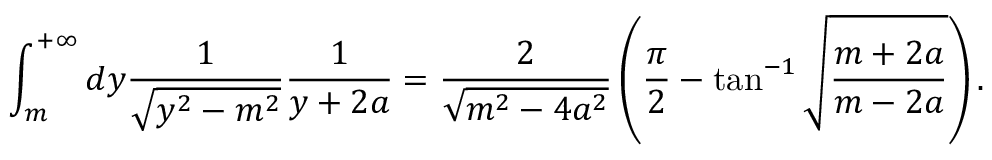Convert formula to latex. <formula><loc_0><loc_0><loc_500><loc_500>\int _ { m } ^ { + \infty } d y \frac { 1 } { \sqrt { y ^ { 2 } - m ^ { 2 } } } \frac { 1 } { y + 2 a } = \frac { 2 } { \sqrt { m ^ { 2 } - 4 a ^ { 2 } } } \left ( \frac { \pi } { 2 } - \tan ^ { - 1 } \sqrt { \frac { m + 2 a } { m - 2 a } } \right ) .</formula> 